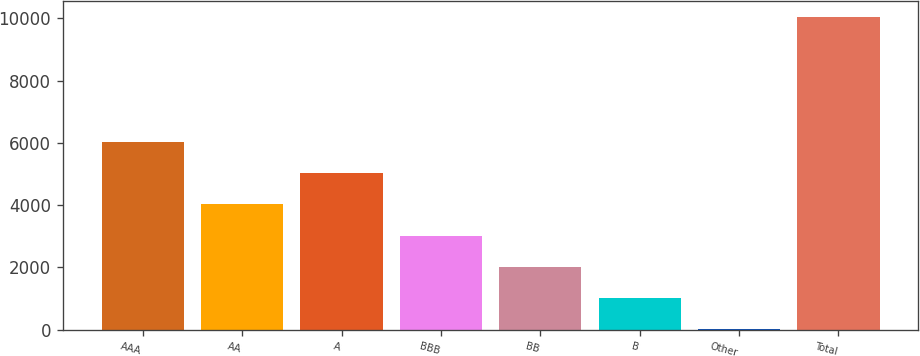Convert chart. <chart><loc_0><loc_0><loc_500><loc_500><bar_chart><fcel>AAA<fcel>AA<fcel>A<fcel>BBB<fcel>BB<fcel>B<fcel>Other<fcel>Total<nl><fcel>6029.66<fcel>4023.44<fcel>5026.55<fcel>3020.33<fcel>2017.22<fcel>1014.11<fcel>11<fcel>10042.1<nl></chart> 